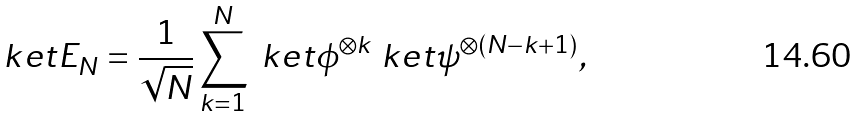<formula> <loc_0><loc_0><loc_500><loc_500>\ k e t { E _ { N } } = \frac { 1 } { \sqrt { N } } \sum _ { k = 1 } ^ { N } \ k e t { \phi } ^ { \otimes k } \ k e t { \psi } ^ { \otimes ( N - k + 1 ) } ,</formula> 